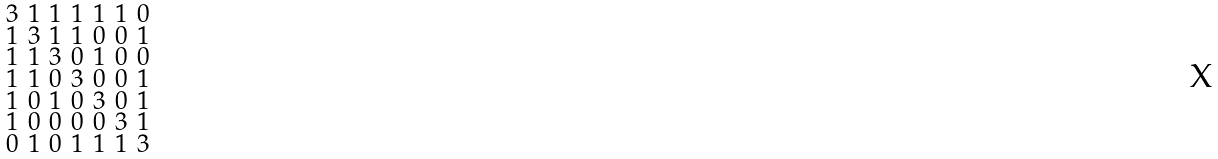<formula> <loc_0><loc_0><loc_500><loc_500>\begin{smallmatrix} 3 & 1 & 1 & 1 & 1 & 1 & 0 \\ 1 & 3 & 1 & 1 & 0 & 0 & 1 \\ 1 & 1 & 3 & 0 & 1 & 0 & 0 \\ 1 & 1 & 0 & 3 & 0 & 0 & 1 \\ 1 & 0 & 1 & 0 & 3 & 0 & 1 \\ 1 & 0 & 0 & 0 & 0 & 3 & 1 \\ 0 & 1 & 0 & 1 & 1 & 1 & 3 \end{smallmatrix}</formula> 